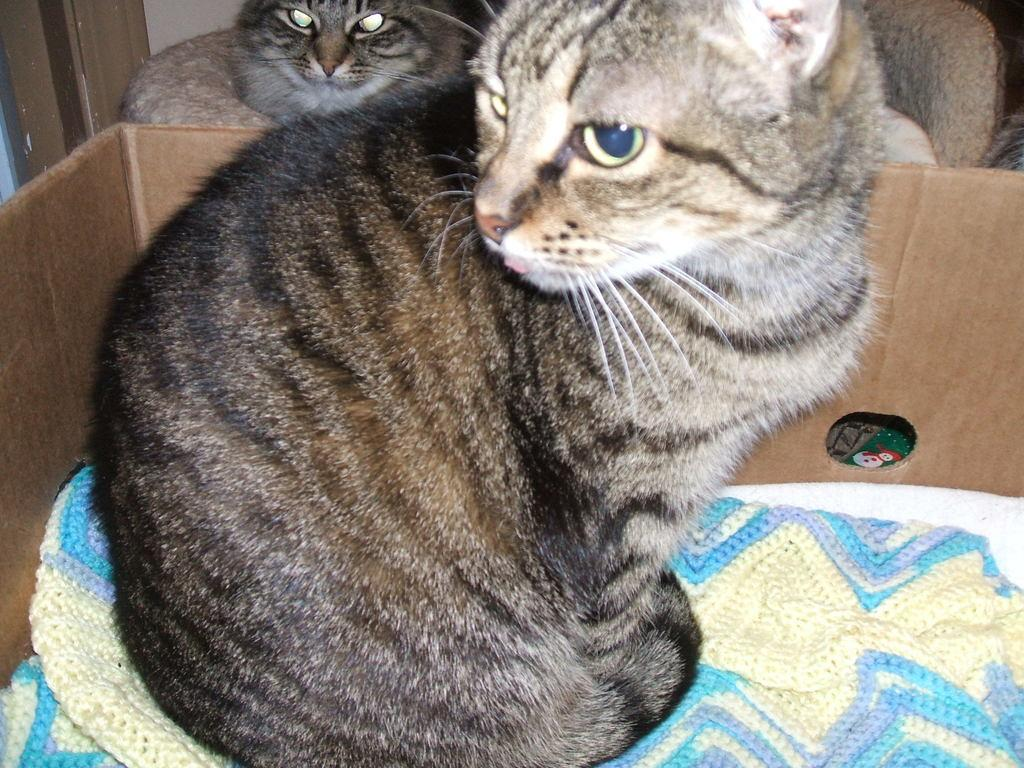What is located in the foreground of the picture? There is a box in the foreground of the picture. What is inside the box? The box contains clothes. Is there any animal present in the box? Yes, there is a cat in the box. What can be seen in the background of the picture? There is a cat on a couch in the background. What is on the left side of the image? There is a wooden object on the left side of the image. What is the current status of the porter in the image? There is no porter present in the image. Can you describe how the cat is running in the image? The cat is not running in the image; it is either sitting or lying down in the box and on the couch. 